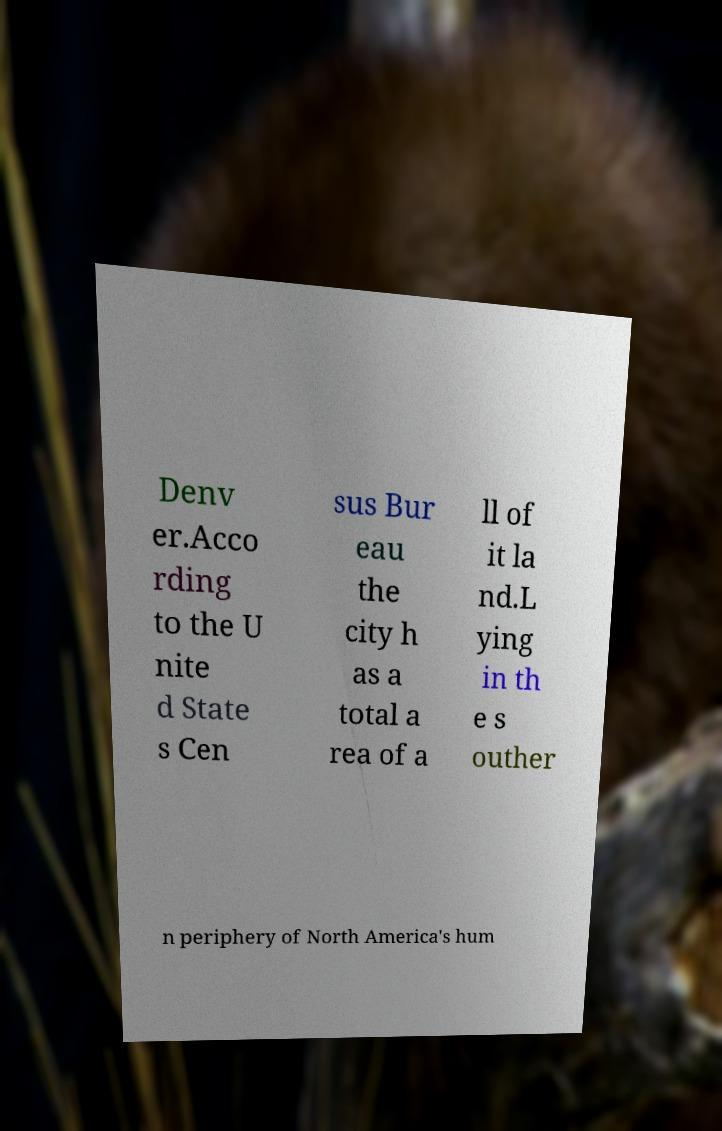What messages or text are displayed in this image? I need them in a readable, typed format. Denv er.Acco rding to the U nite d State s Cen sus Bur eau the city h as a total a rea of a ll of it la nd.L ying in th e s outher n periphery of North America's hum 